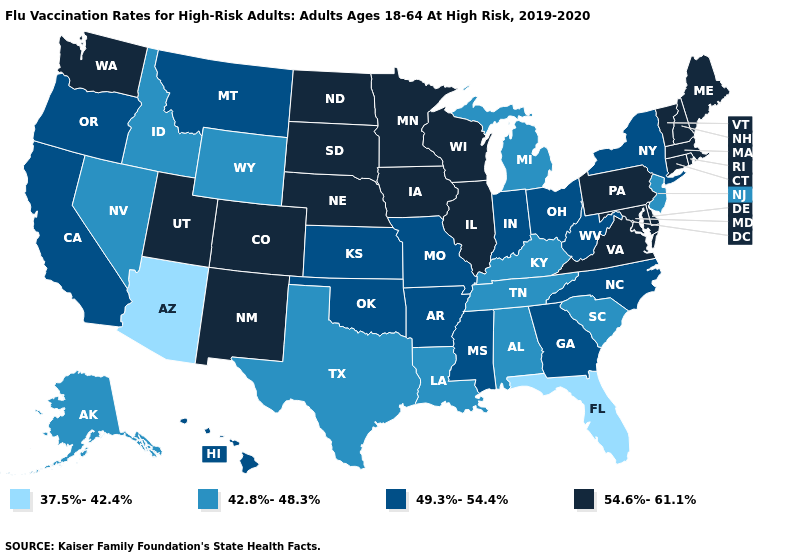Name the states that have a value in the range 42.8%-48.3%?
Keep it brief. Alabama, Alaska, Idaho, Kentucky, Louisiana, Michigan, Nevada, New Jersey, South Carolina, Tennessee, Texas, Wyoming. Among the states that border Colorado , does Utah have the highest value?
Answer briefly. Yes. Among the states that border Kentucky , which have the highest value?
Keep it brief. Illinois, Virginia. Name the states that have a value in the range 54.6%-61.1%?
Keep it brief. Colorado, Connecticut, Delaware, Illinois, Iowa, Maine, Maryland, Massachusetts, Minnesota, Nebraska, New Hampshire, New Mexico, North Dakota, Pennsylvania, Rhode Island, South Dakota, Utah, Vermont, Virginia, Washington, Wisconsin. Among the states that border Kansas , which have the highest value?
Quick response, please. Colorado, Nebraska. Does Iowa have the lowest value in the USA?
Give a very brief answer. No. Does Washington have the highest value in the USA?
Concise answer only. Yes. Does Arkansas have a higher value than West Virginia?
Keep it brief. No. What is the highest value in the South ?
Answer briefly. 54.6%-61.1%. Does Indiana have the same value as Hawaii?
Write a very short answer. Yes. What is the value of West Virginia?
Short answer required. 49.3%-54.4%. What is the highest value in states that border New Jersey?
Answer briefly. 54.6%-61.1%. What is the lowest value in states that border North Dakota?
Keep it brief. 49.3%-54.4%. Name the states that have a value in the range 37.5%-42.4%?
Short answer required. Arizona, Florida. Does Connecticut have the highest value in the Northeast?
Quick response, please. Yes. 